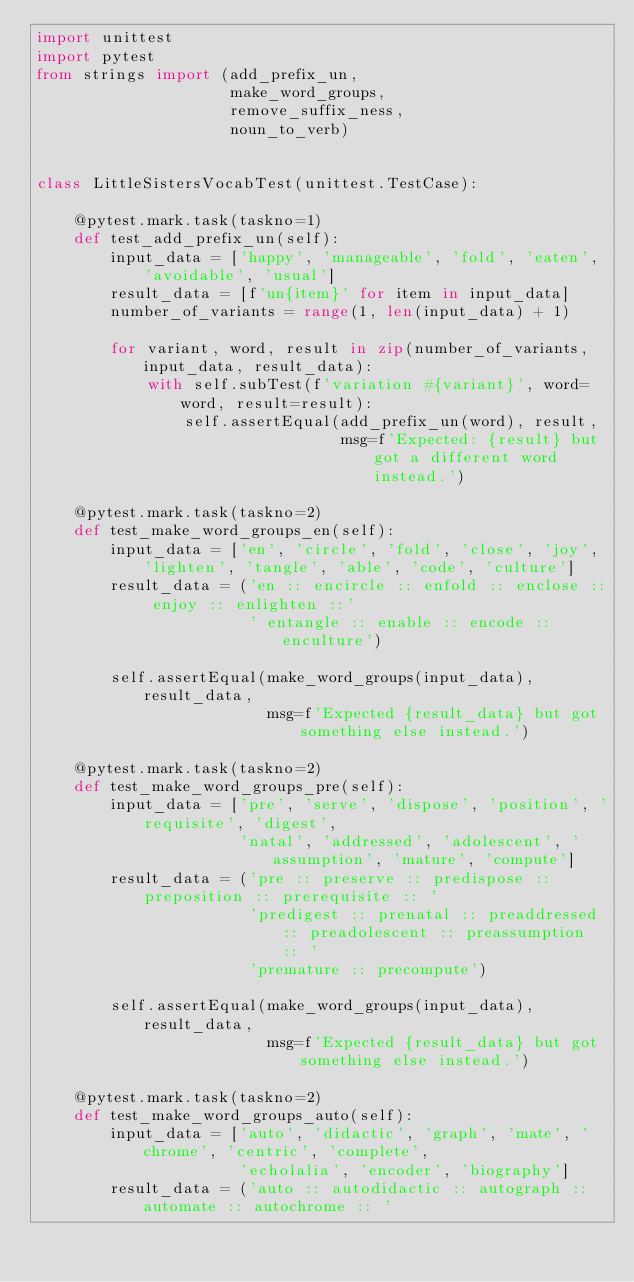Convert code to text. <code><loc_0><loc_0><loc_500><loc_500><_Python_>import unittest
import pytest
from strings import (add_prefix_un,
                     make_word_groups,
                     remove_suffix_ness,
                     noun_to_verb)


class LittleSistersVocabTest(unittest.TestCase):

    @pytest.mark.task(taskno=1)
    def test_add_prefix_un(self):
        input_data = ['happy', 'manageable', 'fold', 'eaten', 'avoidable', 'usual']
        result_data = [f'un{item}' for item in input_data]
        number_of_variants = range(1, len(input_data) + 1)

        for variant, word, result in zip(number_of_variants, input_data, result_data):
            with self.subTest(f'variation #{variant}', word=word, result=result):
                self.assertEqual(add_prefix_un(word), result,
                                 msg=f'Expected: {result} but got a different word instead.')

    @pytest.mark.task(taskno=2)
    def test_make_word_groups_en(self):
        input_data = ['en', 'circle', 'fold', 'close', 'joy', 'lighten', 'tangle', 'able', 'code', 'culture']
        result_data = ('en :: encircle :: enfold :: enclose :: enjoy :: enlighten ::'
                       ' entangle :: enable :: encode :: enculture')

        self.assertEqual(make_word_groups(input_data), result_data,
                         msg=f'Expected {result_data} but got something else instead.')

    @pytest.mark.task(taskno=2)
    def test_make_word_groups_pre(self):
        input_data = ['pre', 'serve', 'dispose', 'position', 'requisite', 'digest',
                      'natal', 'addressed', 'adolescent', 'assumption', 'mature', 'compute']
        result_data = ('pre :: preserve :: predispose :: preposition :: prerequisite :: '
                       'predigest :: prenatal :: preaddressed :: preadolescent :: preassumption :: '
                       'premature :: precompute')

        self.assertEqual(make_word_groups(input_data), result_data,
                         msg=f'Expected {result_data} but got something else instead.')

    @pytest.mark.task(taskno=2)
    def test_make_word_groups_auto(self):
        input_data = ['auto', 'didactic', 'graph', 'mate', 'chrome', 'centric', 'complete',
                      'echolalia', 'encoder', 'biography']
        result_data = ('auto :: autodidactic :: autograph :: automate :: autochrome :: '</code> 